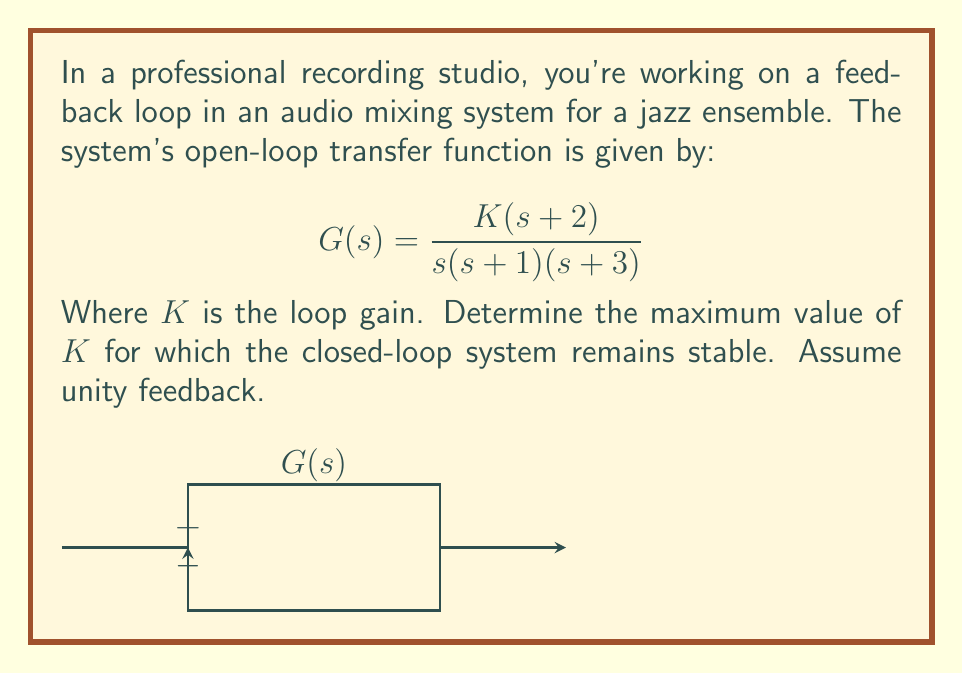Help me with this question. To determine the stability of the closed-loop system, we'll use the Routh-Hurwitz criterion. Let's approach this step-by-step:

1) First, we need to find the characteristic equation of the closed-loop system. The closed-loop transfer function is:

   $$T(s) = \frac{G(s)}{1+G(s)} = \frac{K(s+2)}{s(s+1)(s+3)+K(s+2)}$$

2) The characteristic equation is the denominator set to zero:

   $$s(s+1)(s+3)+K(s+2) = 0$$

3) Expanding this:

   $$s^3 + 4s^2 + 3s + K(s+2) = 0$$
   $$s^3 + 4s^2 + (3+K)s + 2K = 0$$

4) Now, let's construct the Routh array:

   $$\begin{array}{c|c}
   s^3 & 1 & 3+K \\
   s^2 & 4 & 2K \\
   s^1 & \frac{4(3+K)-1(2K)}{4} = 3+\frac{K}{2} & 0 \\
   s^0 & 2K & 0
   \end{array}$$

5) For stability, all elements in the first column must be positive. We already know that 1 and 4 are positive, so we need:

   $$3+\frac{K}{2} > 0 \text{ and } 2K > 0$$

6) From $2K > 0$, we get $K > 0$. 
   From $3+\frac{K}{2} > 0$, we get $K > -6$.

7) Combining these conditions, we have $K > 0$.

8) However, we need to find the maximum value of $K$. As $K$ increases, the system will become unstable when the term $3+\frac{K}{2}$ becomes zero.

9) Solving $3+\frac{K}{2} = 0$:
   
   $$K = -6$$

Therefore, the maximum value of $K$ for stability is just below 6.
Answer: $K < 6$ 